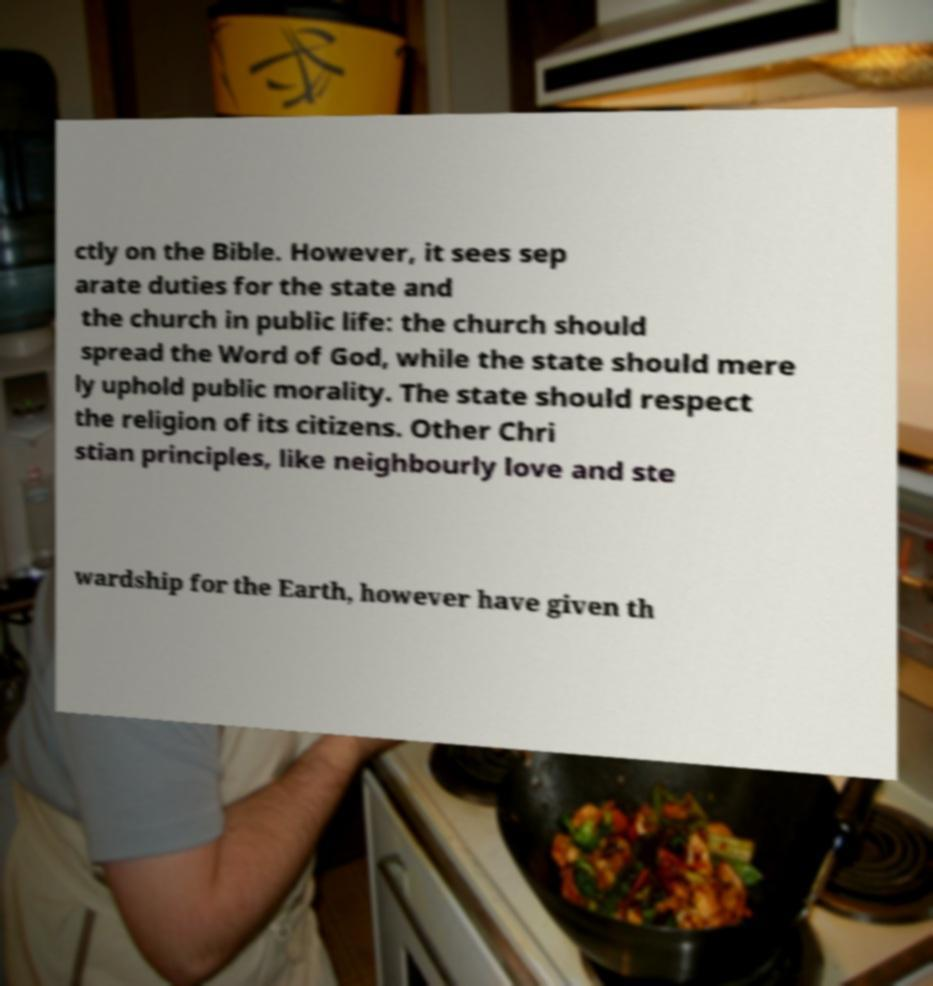For documentation purposes, I need the text within this image transcribed. Could you provide that? ctly on the Bible. However, it sees sep arate duties for the state and the church in public life: the church should spread the Word of God, while the state should mere ly uphold public morality. The state should respect the religion of its citizens. Other Chri stian principles, like neighbourly love and ste wardship for the Earth, however have given th 